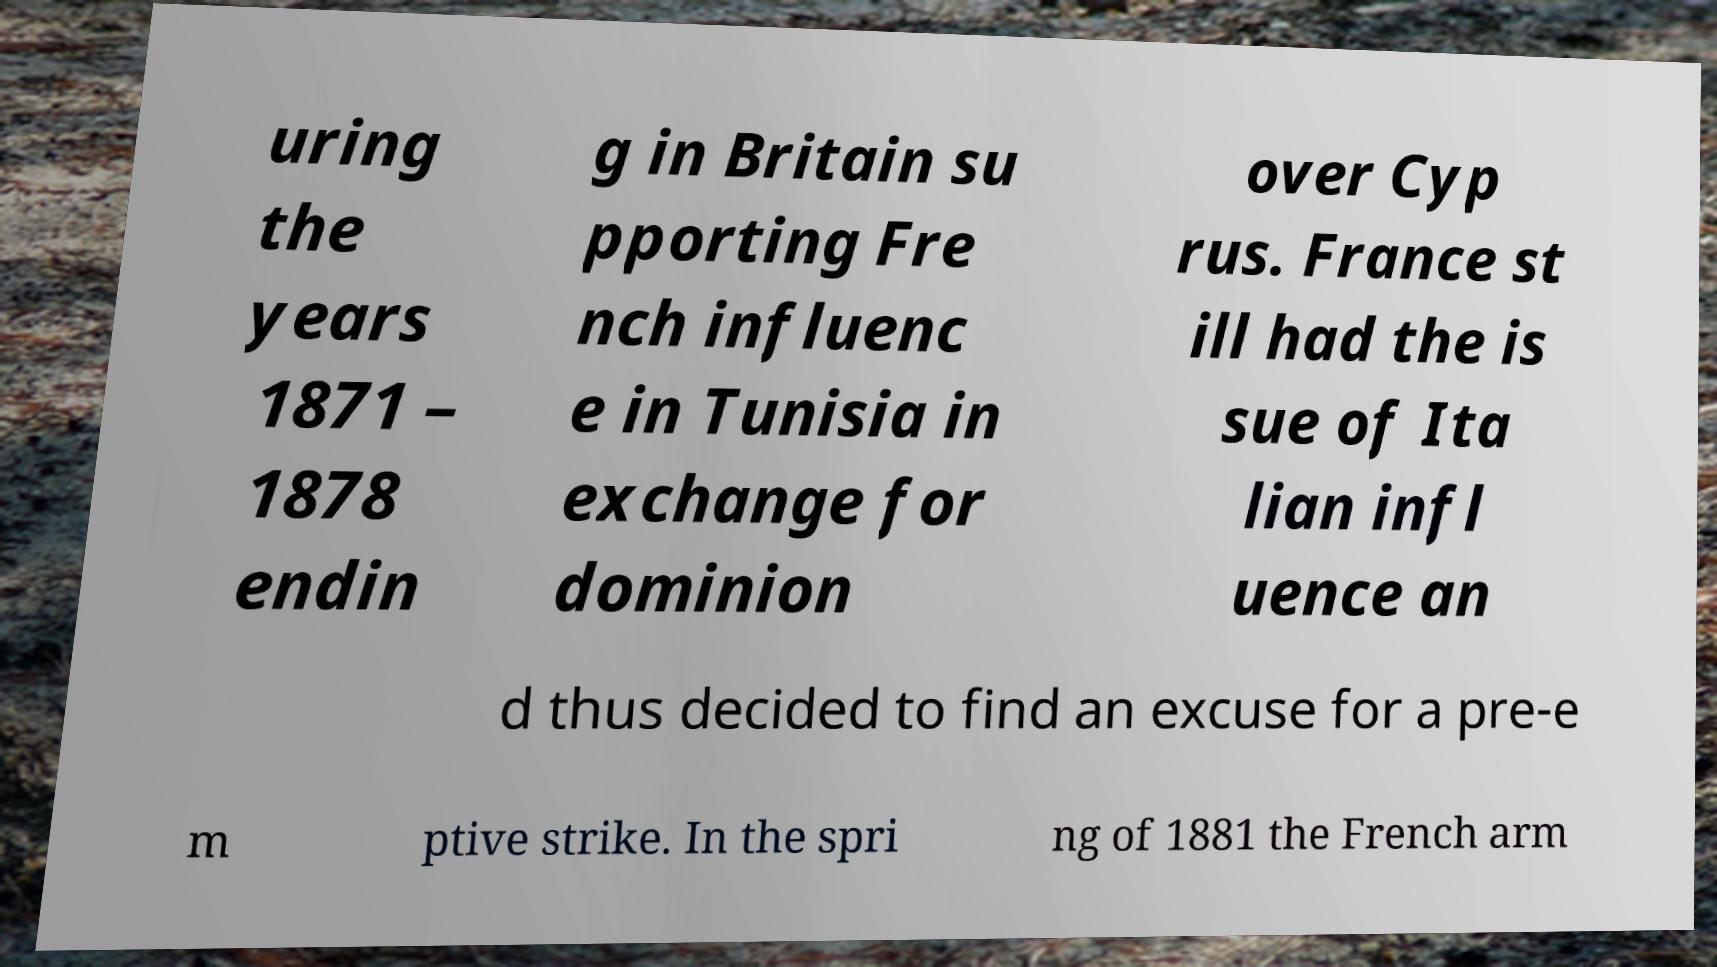Can you read and provide the text displayed in the image?This photo seems to have some interesting text. Can you extract and type it out for me? uring the years 1871 – 1878 endin g in Britain su pporting Fre nch influenc e in Tunisia in exchange for dominion over Cyp rus. France st ill had the is sue of Ita lian infl uence an d thus decided to find an excuse for a pre-e m ptive strike. In the spri ng of 1881 the French arm 